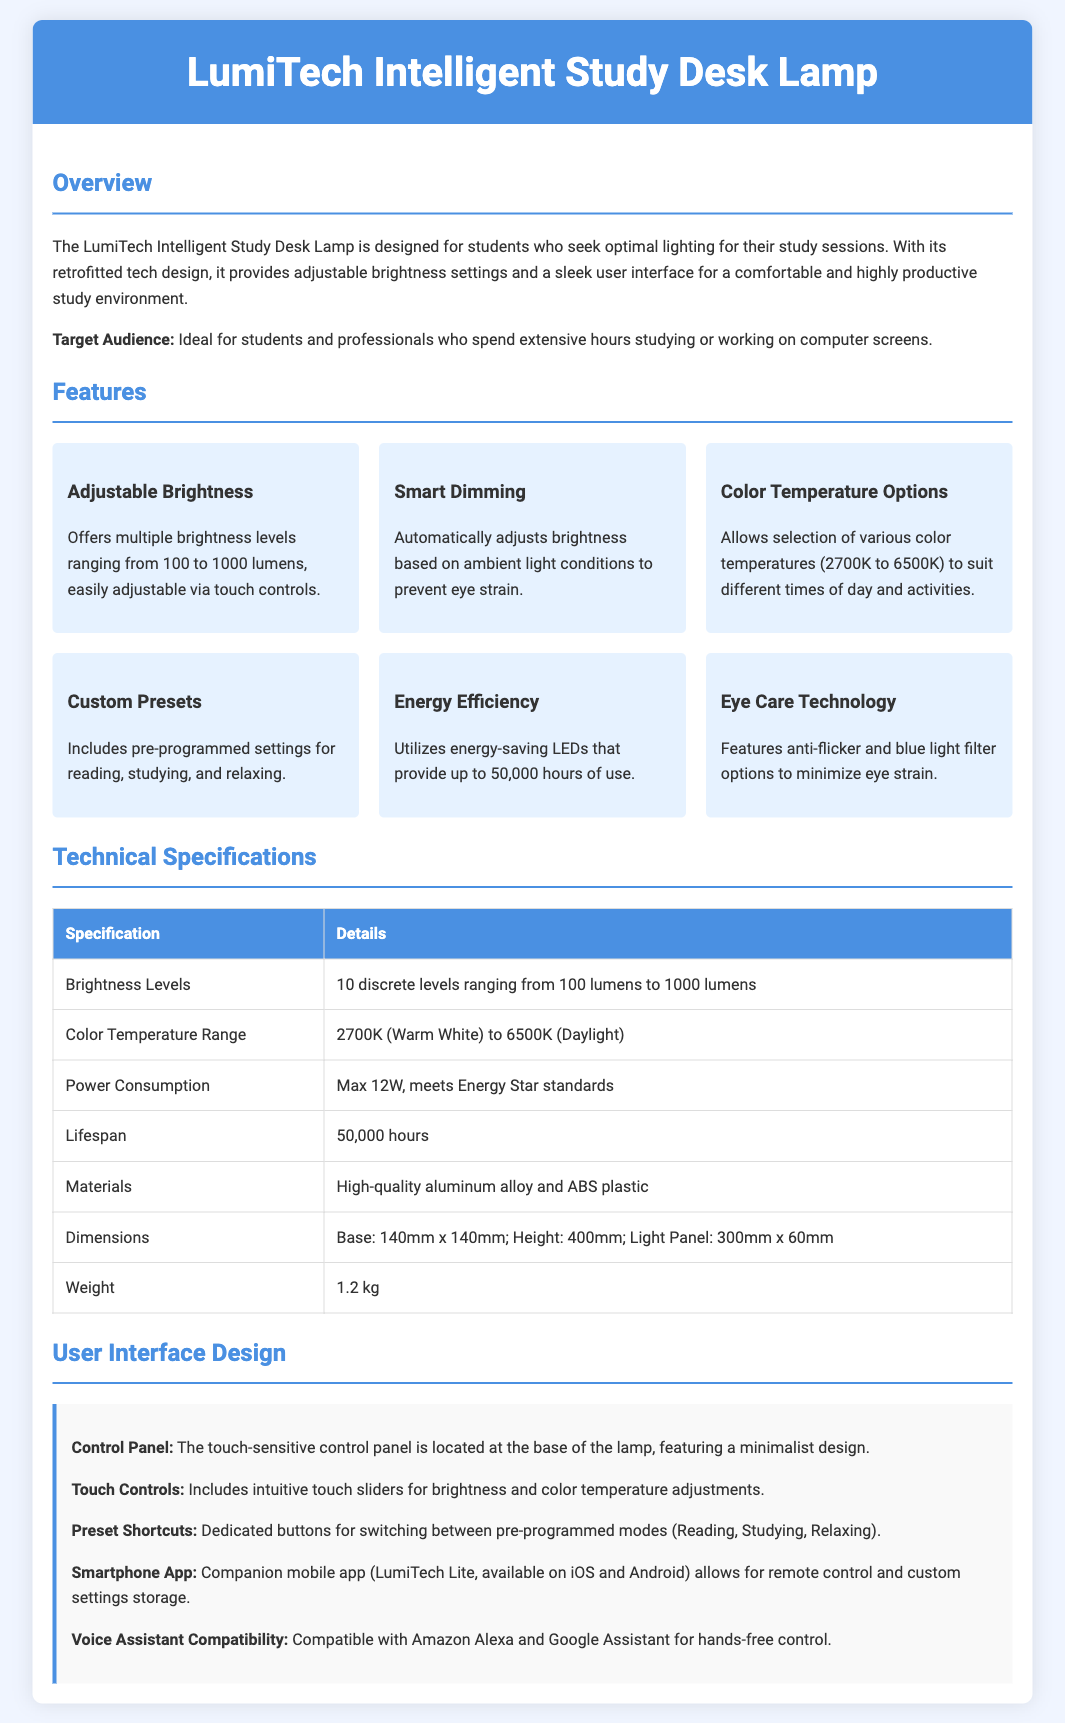What is the brightness range of the lamp? The brightness range is detailed in the features section, where it states that the lamp offers multiple brightness levels ranging from 100 to 1000 lumens.
Answer: 100 to 1000 lumens What are the color temperature options? The color temperature options are specified in the features section, stating that it allows selection of various color temperatures from 2700K to 6500K.
Answer: 2700K to 6500K How many discrete brightness levels does the lamp have? The technical specifications mention that the lamp has 10 discrete brightness levels.
Answer: 10 What is the maximum power consumption of the lamp? The technical specifications section specifies that the maximum power consumption is 12W.
Answer: 12W Which materials make up the lamp? The materials used for the lamp are listed in the technical specifications as high-quality aluminum alloy and ABS plastic.
Answer: Aluminum alloy and ABS plastic What feature helps minimize eye strain? The features section includes a mention of Eye Care Technology, which helps minimize eye strain.
Answer: Eye Care Technology How can the lamp be controlled remotely? The user interface design mentions the companion mobile app LumiTech Lite allows for remote control.
Answer: Smartphone App Which voice assistants are compatible with the lamp? The user interface design section specifies compatibility with Amazon Alexa and Google Assistant for hands-free control.
Answer: Amazon Alexa and Google Assistant 